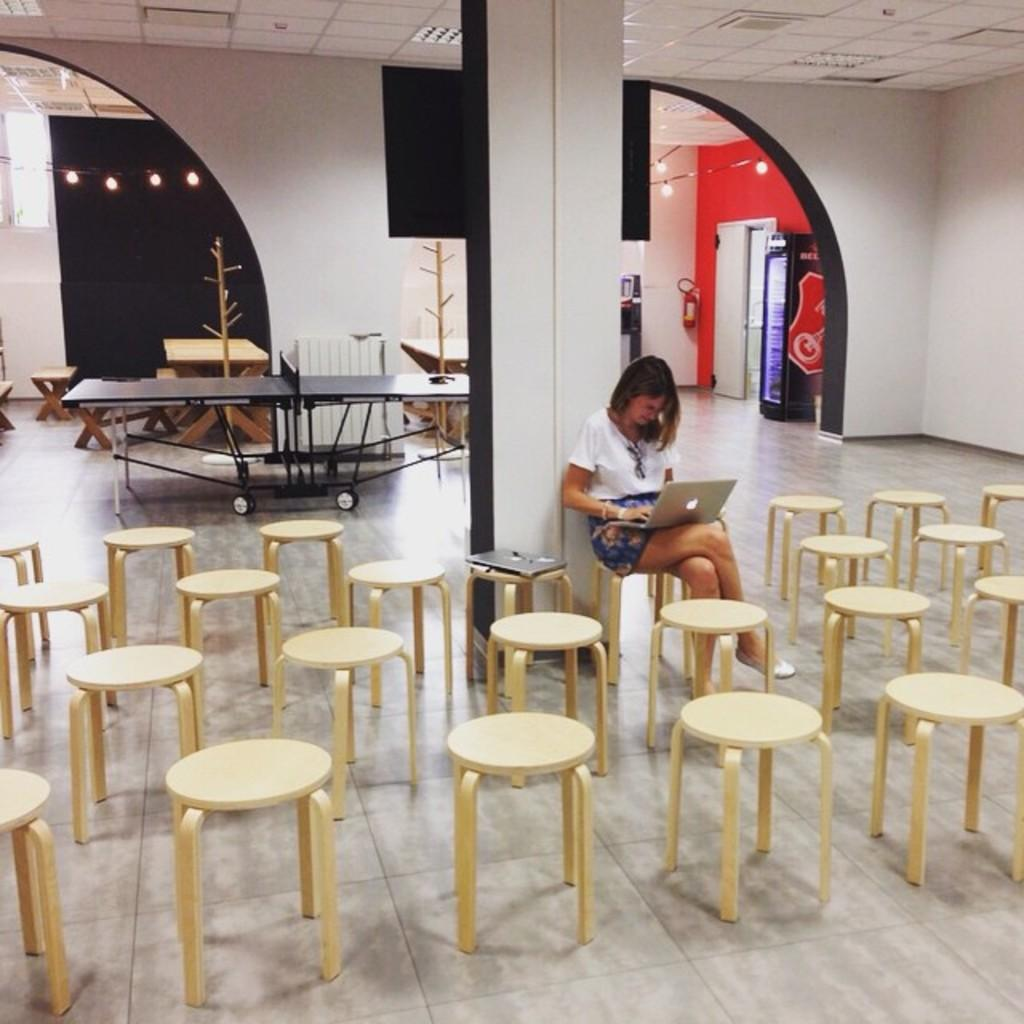What objects are on the floor in the image? There are chairs on the floor in the image. What is the woman doing while sitting on one of the chairs? The woman is working on a laptop. What type of game can be seen in the image? There is a table tennis board visible in the image. What is behind the chairs in the image? There is a wall behind the chairs. What can be seen providing illumination in the image? Lights are present in the image. What type of order is the woman giving to the spring in the image? There is no spring or order present in the image; the woman is working on a laptop. 